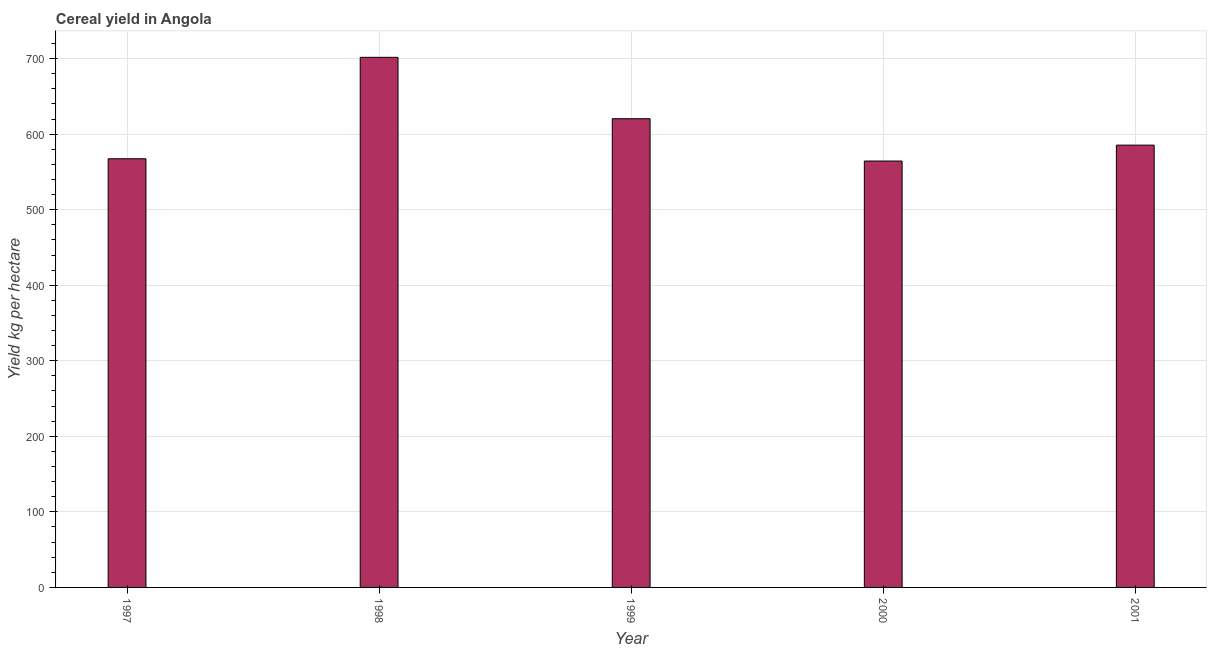What is the title of the graph?
Provide a short and direct response. Cereal yield in Angola. What is the label or title of the X-axis?
Offer a terse response. Year. What is the label or title of the Y-axis?
Your answer should be very brief. Yield kg per hectare. What is the cereal yield in 1999?
Provide a short and direct response. 620.38. Across all years, what is the maximum cereal yield?
Offer a very short reply. 701.64. Across all years, what is the minimum cereal yield?
Keep it short and to the point. 564.37. In which year was the cereal yield minimum?
Your response must be concise. 2000. What is the sum of the cereal yield?
Keep it short and to the point. 3039.21. What is the difference between the cereal yield in 1998 and 2001?
Provide a succinct answer. 116.22. What is the average cereal yield per year?
Ensure brevity in your answer.  607.84. What is the median cereal yield?
Provide a succinct answer. 585.42. In how many years, is the cereal yield greater than 360 kg per hectare?
Keep it short and to the point. 5. What is the ratio of the cereal yield in 1999 to that in 2001?
Your response must be concise. 1.06. Is the difference between the cereal yield in 1997 and 2000 greater than the difference between any two years?
Give a very brief answer. No. What is the difference between the highest and the second highest cereal yield?
Offer a very short reply. 81.27. Is the sum of the cereal yield in 1997 and 1998 greater than the maximum cereal yield across all years?
Your answer should be very brief. Yes. What is the difference between the highest and the lowest cereal yield?
Give a very brief answer. 137.27. Are the values on the major ticks of Y-axis written in scientific E-notation?
Provide a short and direct response. No. What is the Yield kg per hectare of 1997?
Provide a succinct answer. 567.4. What is the Yield kg per hectare in 1998?
Give a very brief answer. 701.64. What is the Yield kg per hectare in 1999?
Ensure brevity in your answer.  620.38. What is the Yield kg per hectare of 2000?
Offer a very short reply. 564.37. What is the Yield kg per hectare in 2001?
Provide a succinct answer. 585.42. What is the difference between the Yield kg per hectare in 1997 and 1998?
Provide a succinct answer. -134.24. What is the difference between the Yield kg per hectare in 1997 and 1999?
Your response must be concise. -52.98. What is the difference between the Yield kg per hectare in 1997 and 2000?
Offer a terse response. 3.02. What is the difference between the Yield kg per hectare in 1997 and 2001?
Make the answer very short. -18.02. What is the difference between the Yield kg per hectare in 1998 and 1999?
Your answer should be compact. 81.27. What is the difference between the Yield kg per hectare in 1998 and 2000?
Keep it short and to the point. 137.27. What is the difference between the Yield kg per hectare in 1998 and 2001?
Ensure brevity in your answer.  116.22. What is the difference between the Yield kg per hectare in 1999 and 2000?
Keep it short and to the point. 56. What is the difference between the Yield kg per hectare in 1999 and 2001?
Provide a short and direct response. 34.95. What is the difference between the Yield kg per hectare in 2000 and 2001?
Make the answer very short. -21.05. What is the ratio of the Yield kg per hectare in 1997 to that in 1998?
Provide a succinct answer. 0.81. What is the ratio of the Yield kg per hectare in 1997 to that in 1999?
Provide a short and direct response. 0.92. What is the ratio of the Yield kg per hectare in 1997 to that in 2000?
Your answer should be very brief. 1. What is the ratio of the Yield kg per hectare in 1997 to that in 2001?
Provide a succinct answer. 0.97. What is the ratio of the Yield kg per hectare in 1998 to that in 1999?
Offer a very short reply. 1.13. What is the ratio of the Yield kg per hectare in 1998 to that in 2000?
Provide a succinct answer. 1.24. What is the ratio of the Yield kg per hectare in 1998 to that in 2001?
Provide a succinct answer. 1.2. What is the ratio of the Yield kg per hectare in 1999 to that in 2000?
Offer a very short reply. 1.1. What is the ratio of the Yield kg per hectare in 1999 to that in 2001?
Give a very brief answer. 1.06. 